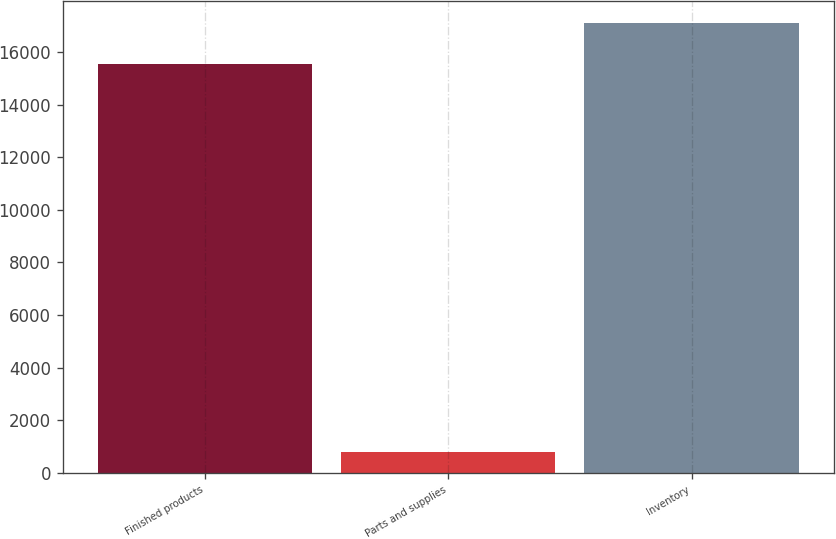Convert chart. <chart><loc_0><loc_0><loc_500><loc_500><bar_chart><fcel>Finished products<fcel>Parts and supplies<fcel>Inventory<nl><fcel>15530<fcel>793<fcel>17083<nl></chart> 